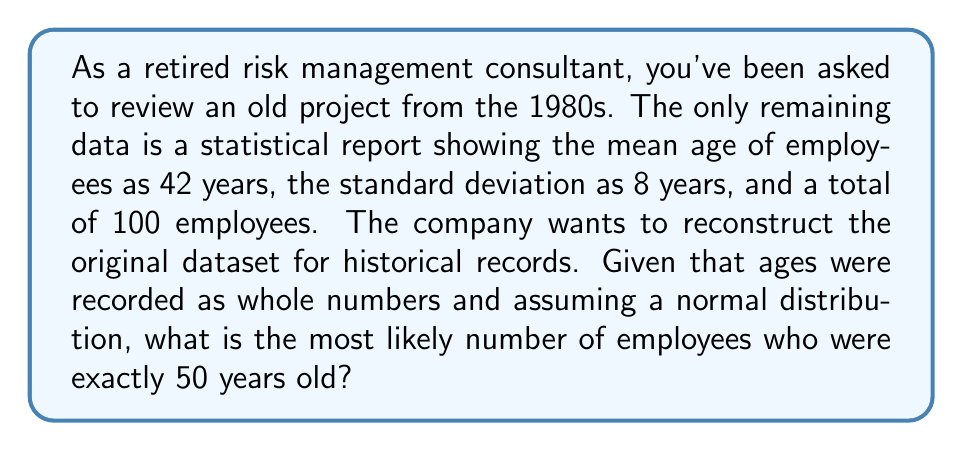Teach me how to tackle this problem. To solve this inverse problem, we'll follow these steps:

1) First, recall that for a normal distribution:
   
   68% of data falls within 1 standard deviation of the mean
   95% of data falls within 2 standard deviations of the mean
   99.7% of data falls within 3 standard deviations of the mean

2) Given:
   Mean (μ) = 42 years
   Standard Deviation (σ) = 8 years
   Total employees = 100

3) To find the probability of an employee being exactly 50 years old:
   
   z-score = $\frac{x - \mu}{\sigma} = \frac{50 - 42}{8} = 1$

4) Using a standard normal distribution table or calculator, we find that the probability of a z-score less than 1 is approximately 0.8413.

5) The probability of being exactly 50 is the difference between the probability of being less than or equal to 50 and the probability of being less than 50:

   P(50) = P(z ≤ 1) - P(z < 1) ≈ 0.8413 - 0.8389 = 0.0024

6) Given 100 employees, the expected number at age 50 is:

   100 * 0.0024 = 0.24

7) Since we're dealing with whole numbers of people, we round to the nearest integer.
Answer: 0 employees 